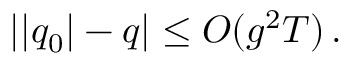Convert formula to latex. <formula><loc_0><loc_0><loc_500><loc_500>| | q _ { 0 } | - q | \leq O ( g ^ { 2 } T ) \, .</formula> 